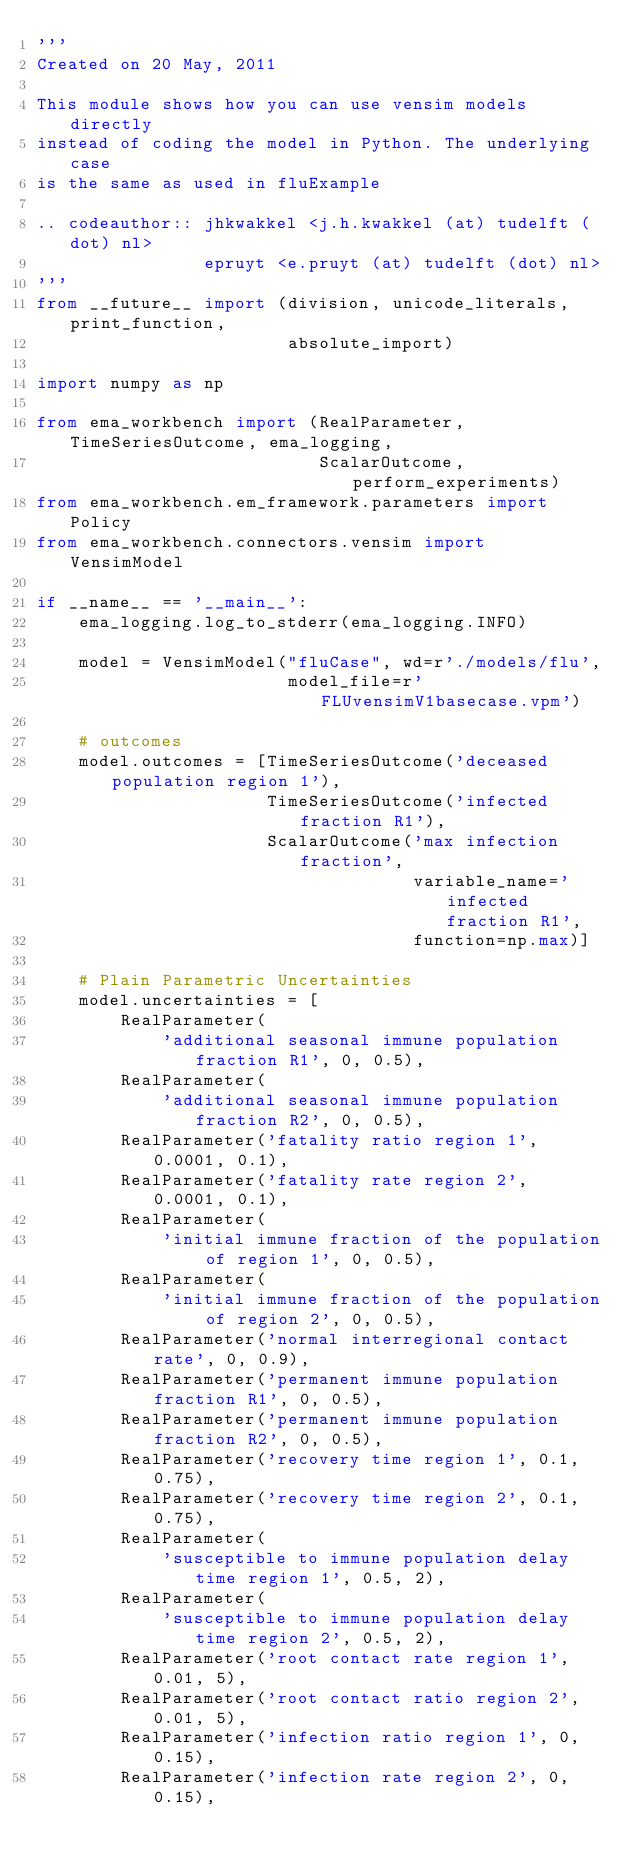<code> <loc_0><loc_0><loc_500><loc_500><_Python_>'''
Created on 20 May, 2011

This module shows how you can use vensim models directly
instead of coding the model in Python. The underlying case
is the same as used in fluExample

.. codeauthor:: jhkwakkel <j.h.kwakkel (at) tudelft (dot) nl>
                epruyt <e.pruyt (at) tudelft (dot) nl>
'''
from __future__ import (division, unicode_literals, print_function,
                        absolute_import)

import numpy as np

from ema_workbench import (RealParameter, TimeSeriesOutcome, ema_logging,
                           ScalarOutcome, perform_experiments)
from ema_workbench.em_framework.parameters import Policy
from ema_workbench.connectors.vensim import VensimModel

if __name__ == '__main__':
    ema_logging.log_to_stderr(ema_logging.INFO)

    model = VensimModel("fluCase", wd=r'./models/flu',
                        model_file=r'FLUvensimV1basecase.vpm')

    # outcomes
    model.outcomes = [TimeSeriesOutcome('deceased population region 1'),
                      TimeSeriesOutcome('infected fraction R1'),
                      ScalarOutcome('max infection fraction',
                                    variable_name='infected fraction R1',
                                    function=np.max)]

    # Plain Parametric Uncertainties
    model.uncertainties = [
        RealParameter(
            'additional seasonal immune population fraction R1', 0, 0.5),
        RealParameter(
            'additional seasonal immune population fraction R2', 0, 0.5),
        RealParameter('fatality ratio region 1', 0.0001, 0.1),
        RealParameter('fatality rate region 2', 0.0001, 0.1),
        RealParameter(
            'initial immune fraction of the population of region 1', 0, 0.5),
        RealParameter(
            'initial immune fraction of the population of region 2', 0, 0.5),
        RealParameter('normal interregional contact rate', 0, 0.9),
        RealParameter('permanent immune population fraction R1', 0, 0.5),
        RealParameter('permanent immune population fraction R2', 0, 0.5),
        RealParameter('recovery time region 1', 0.1, 0.75),
        RealParameter('recovery time region 2', 0.1, 0.75),
        RealParameter(
            'susceptible to immune population delay time region 1', 0.5, 2),
        RealParameter(
            'susceptible to immune population delay time region 2', 0.5, 2),
        RealParameter('root contact rate region 1', 0.01, 5),
        RealParameter('root contact ratio region 2', 0.01, 5),
        RealParameter('infection ratio region 1', 0, 0.15),
        RealParameter('infection rate region 2', 0, 0.15),</code> 